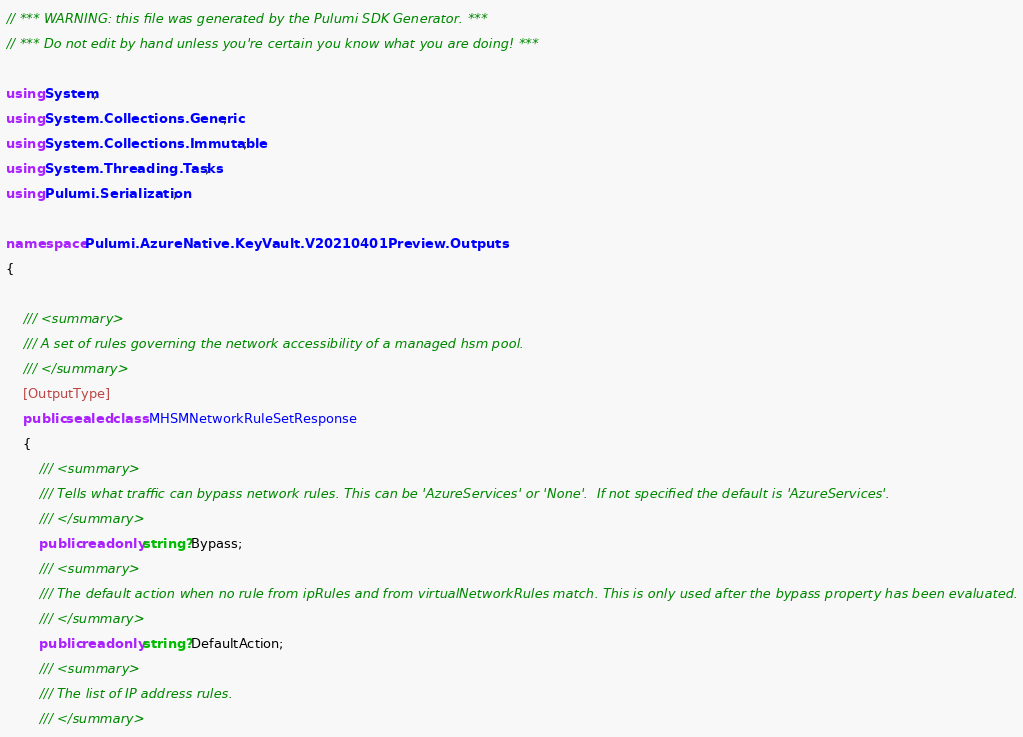<code> <loc_0><loc_0><loc_500><loc_500><_C#_>// *** WARNING: this file was generated by the Pulumi SDK Generator. ***
// *** Do not edit by hand unless you're certain you know what you are doing! ***

using System;
using System.Collections.Generic;
using System.Collections.Immutable;
using System.Threading.Tasks;
using Pulumi.Serialization;

namespace Pulumi.AzureNative.KeyVault.V20210401Preview.Outputs
{

    /// <summary>
    /// A set of rules governing the network accessibility of a managed hsm pool.
    /// </summary>
    [OutputType]
    public sealed class MHSMNetworkRuleSetResponse
    {
        /// <summary>
        /// Tells what traffic can bypass network rules. This can be 'AzureServices' or 'None'.  If not specified the default is 'AzureServices'.
        /// </summary>
        public readonly string? Bypass;
        /// <summary>
        /// The default action when no rule from ipRules and from virtualNetworkRules match. This is only used after the bypass property has been evaluated.
        /// </summary>
        public readonly string? DefaultAction;
        /// <summary>
        /// The list of IP address rules.
        /// </summary></code> 